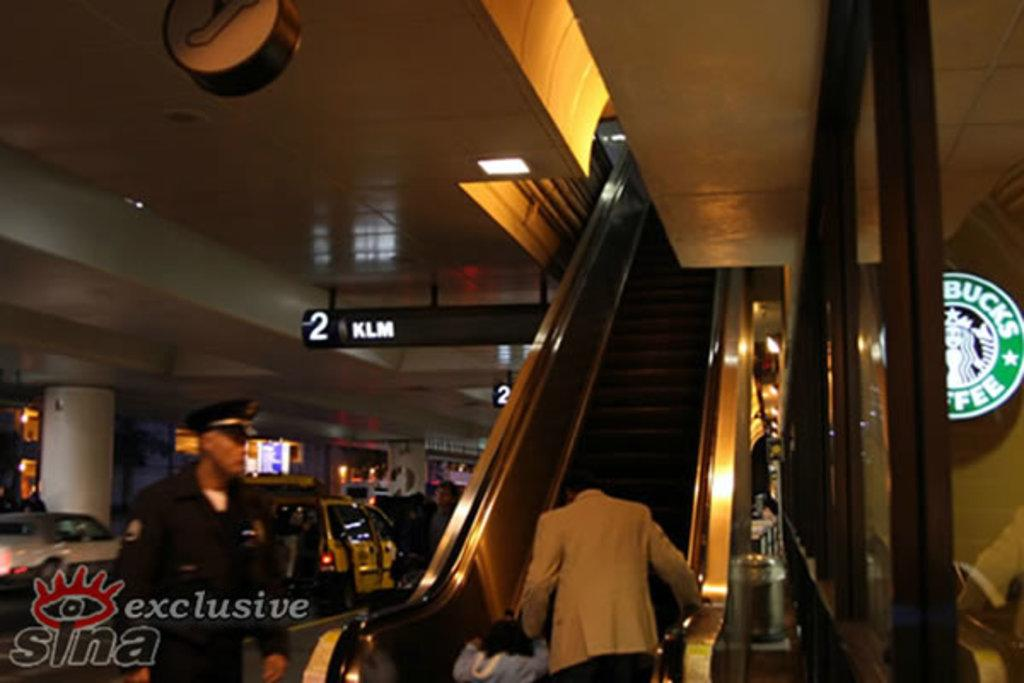<image>
Share a concise interpretation of the image provided. A Starbucks Coffee on the lower level of the building near an escalator 